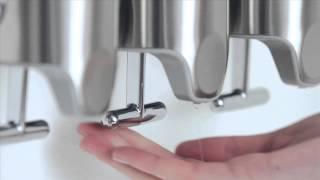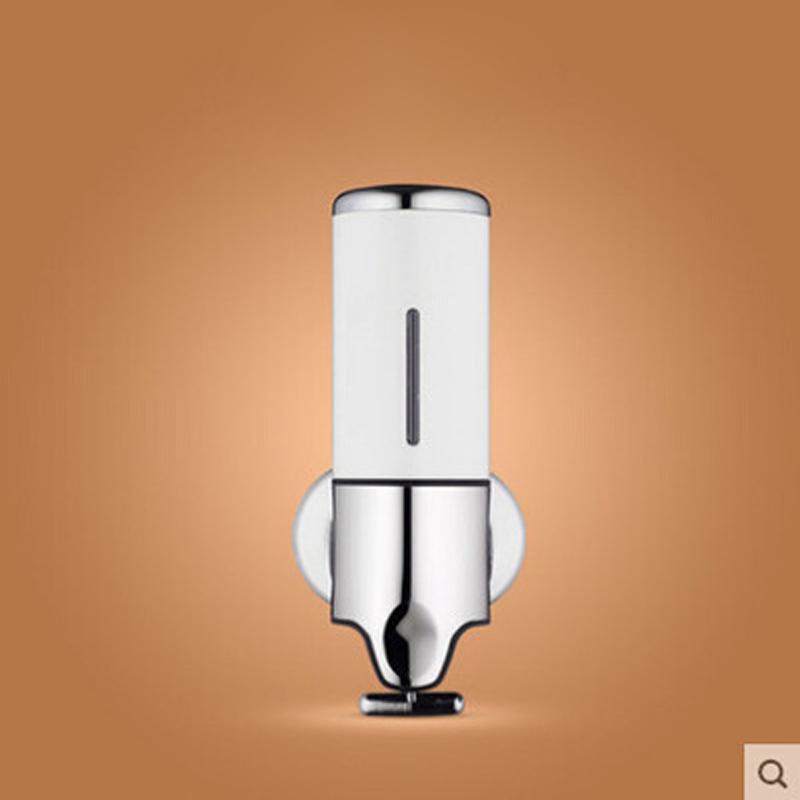The first image is the image on the left, the second image is the image on the right. For the images displayed, is the sentence "The left image contains a human hand." factually correct? Answer yes or no. Yes. 